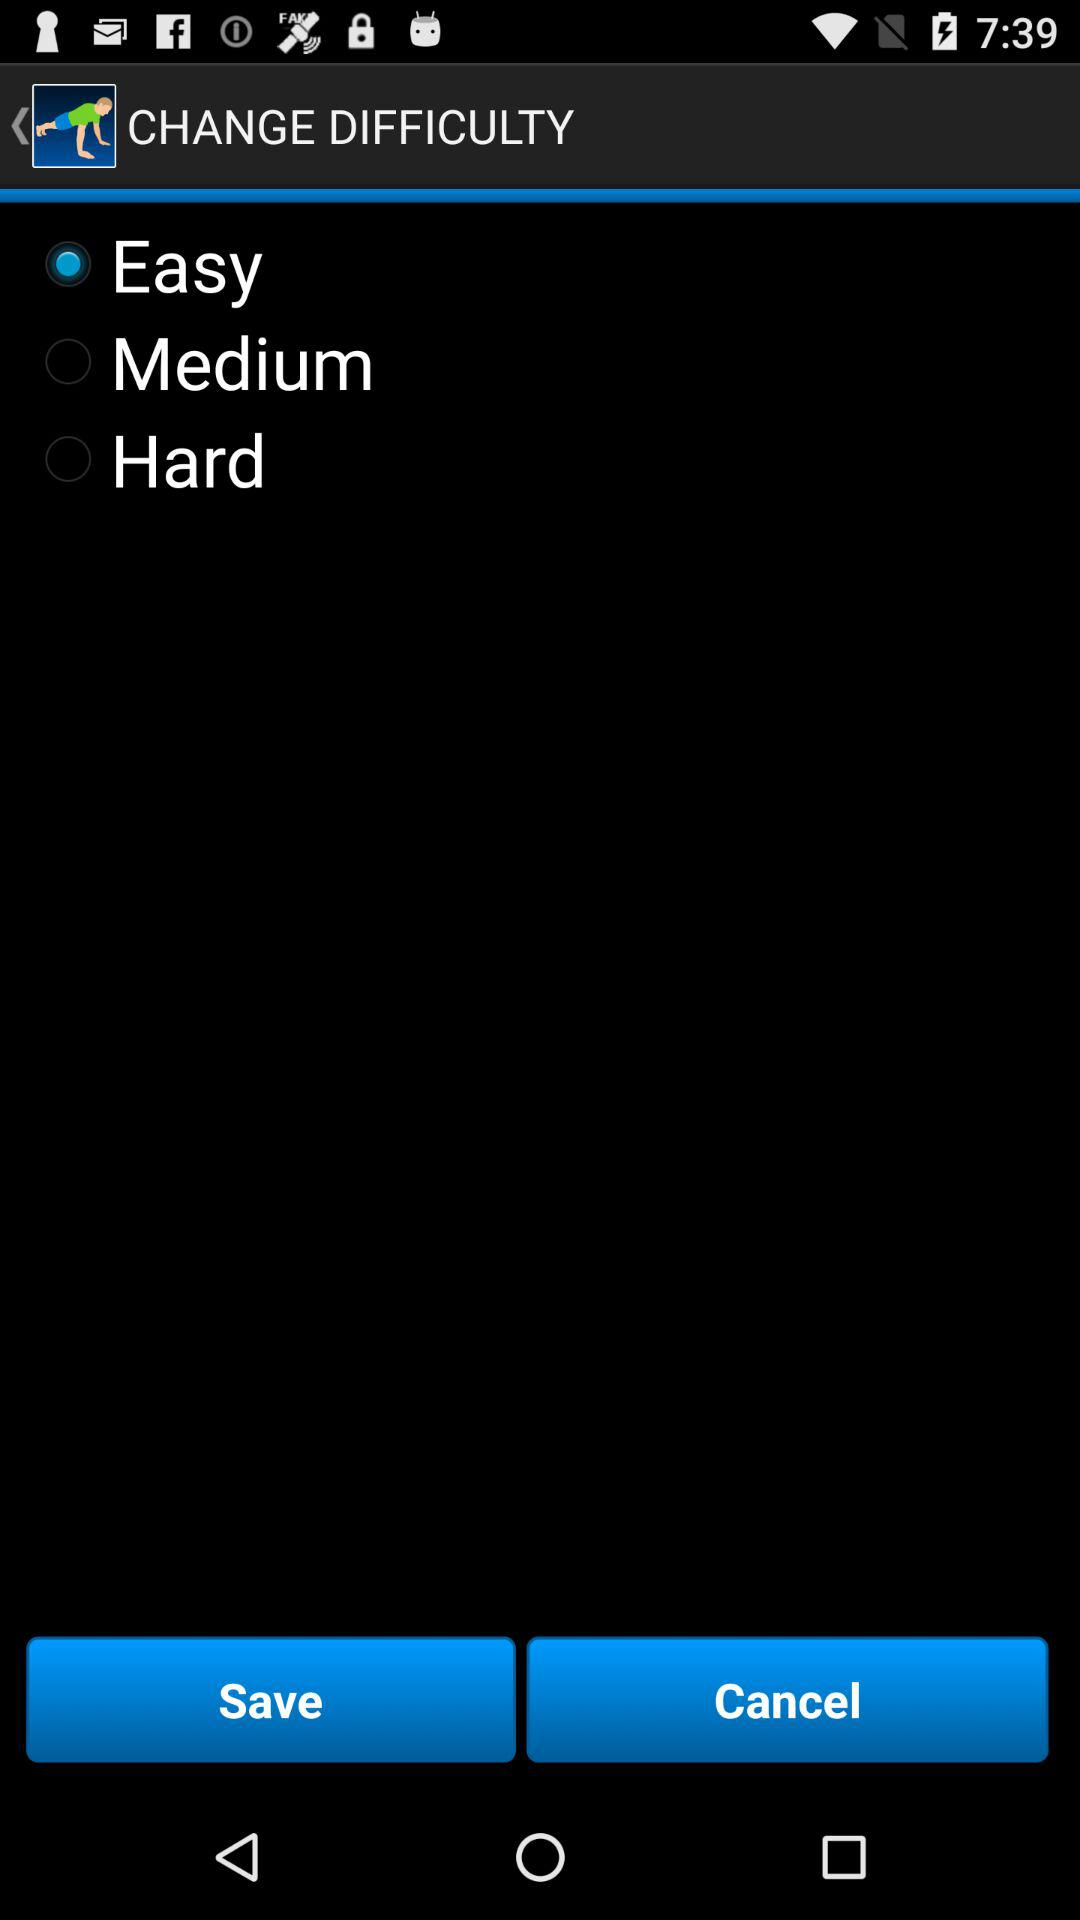Is "Hard" selected or not? "Hard" is not selected. 